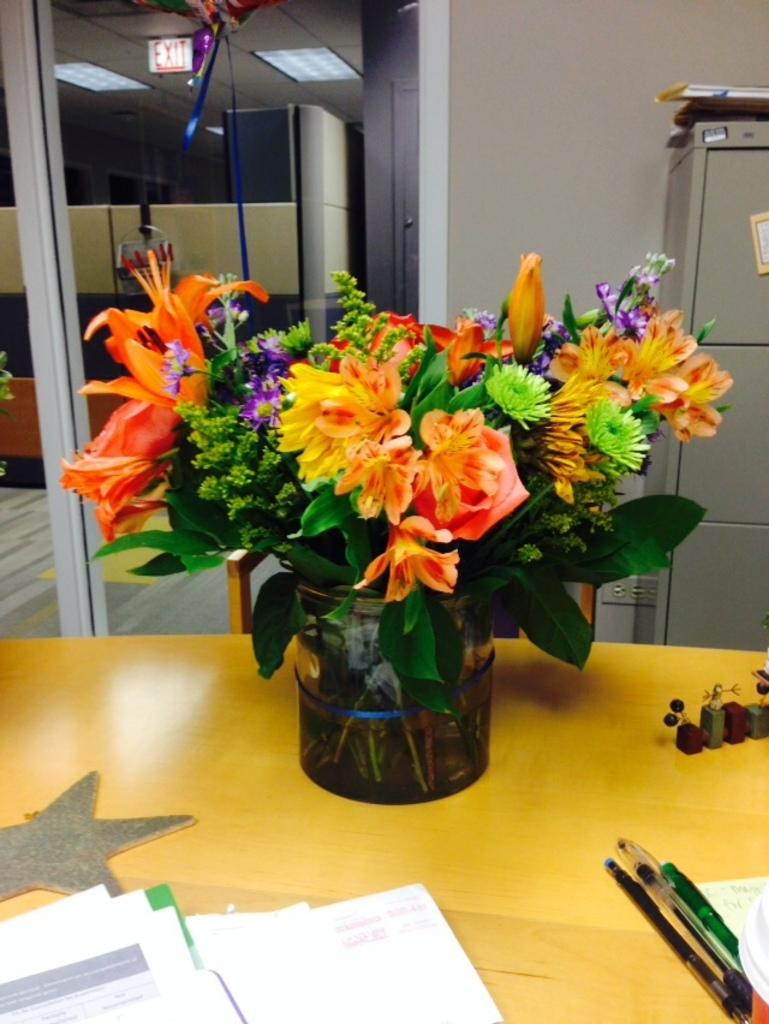What is the main object in the center of the image? There is a flower vase in the center of the image. Where is the flower vase located? The flower vase is on a table. What can be seen at the bottom side of the image? There are papers at the bottom side of the image. What is present in the bottom right side of the image? There is stationary in the bottom right side of the image. What sign can be seen indicating the distance to the nearest town in the image? There is no sign present in the image that indicates the distance to the nearest town. 